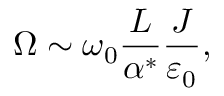<formula> <loc_0><loc_0><loc_500><loc_500>\Omega \sim \omega _ { 0 } \frac { L } { \alpha ^ { * } } \frac { J } { \varepsilon _ { 0 } } ,</formula> 